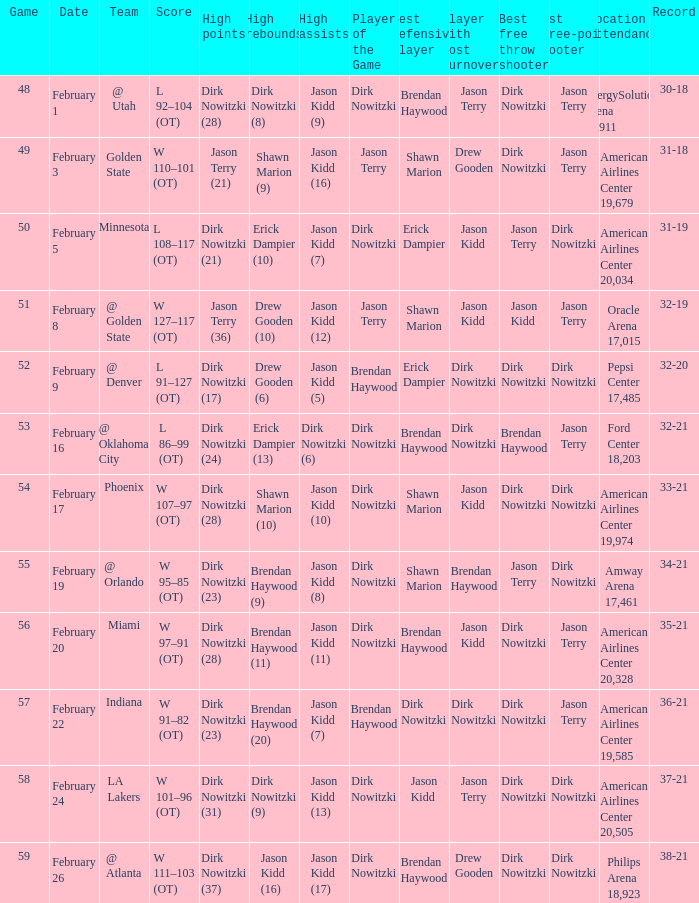Who had the most high assists with a record of 32-19? Jason Kidd (12). 